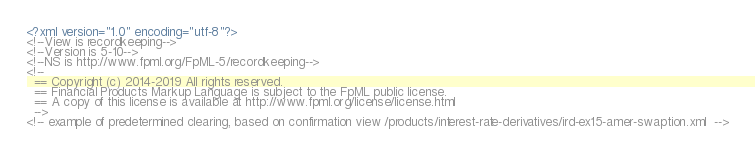<code> <loc_0><loc_0><loc_500><loc_500><_XML_><?xml version="1.0" encoding="utf-8"?>
<!--View is recordkeeping-->
<!--Version is 5-10-->
<!--NS is http://www.fpml.org/FpML-5/recordkeeping-->
<!--
  == Copyright (c) 2014-2019 All rights reserved.
  == Financial Products Markup Language is subject to the FpML public license.
  == A copy of this license is available at http://www.fpml.org/license/license.html
  -->
<!-- example of predetermined clearing, based on confirmation view /products/interest-rate-derivatives/ird-ex15-amer-swaption.xml  --></code> 